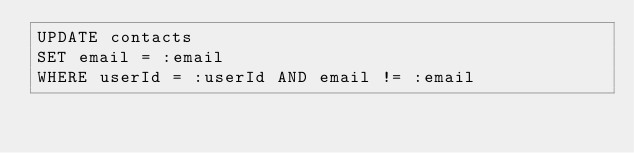<code> <loc_0><loc_0><loc_500><loc_500><_SQL_>UPDATE contacts
SET email = :email
WHERE userId = :userId AND email != :email
</code> 